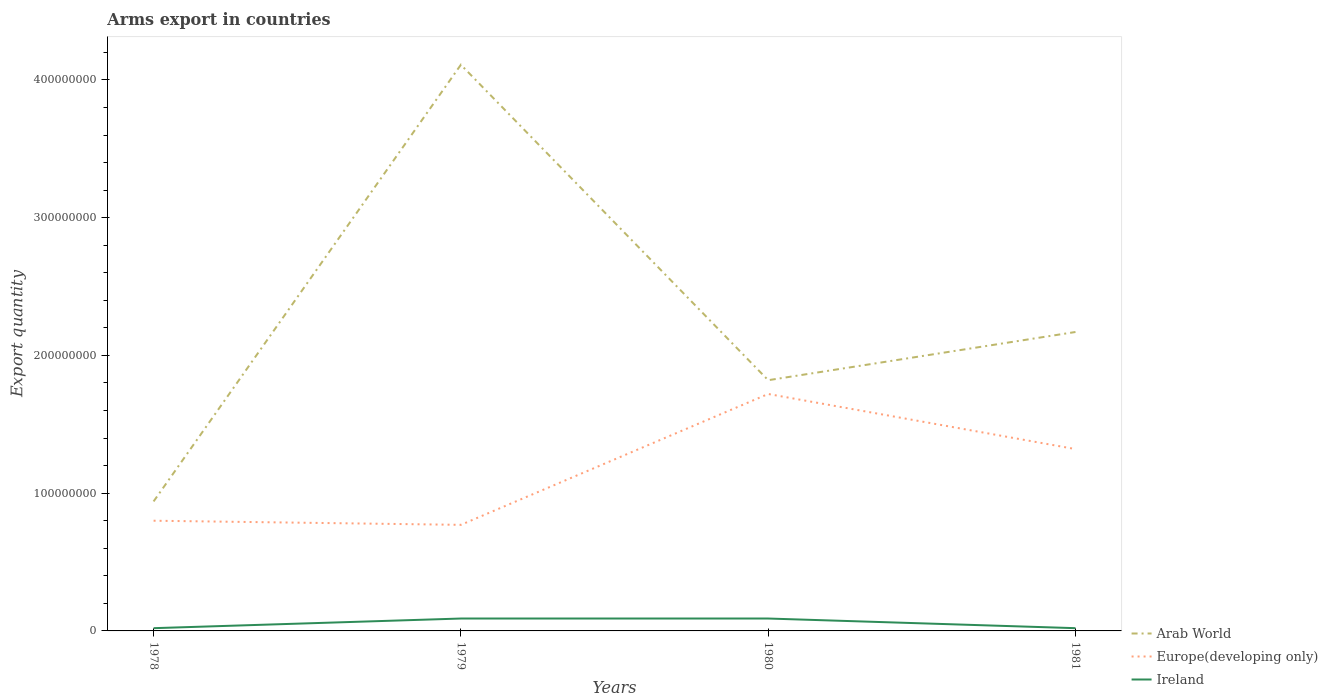Is the number of lines equal to the number of legend labels?
Offer a very short reply. Yes. Across all years, what is the maximum total arms export in Ireland?
Ensure brevity in your answer.  2.00e+06. In which year was the total arms export in Europe(developing only) maximum?
Your response must be concise. 1979. What is the total total arms export in Europe(developing only) in the graph?
Make the answer very short. -9.20e+07. What is the difference between the highest and the lowest total arms export in Europe(developing only)?
Offer a terse response. 2. Is the total arms export in Ireland strictly greater than the total arms export in Europe(developing only) over the years?
Make the answer very short. Yes. How many lines are there?
Provide a succinct answer. 3. Are the values on the major ticks of Y-axis written in scientific E-notation?
Ensure brevity in your answer.  No. Does the graph contain any zero values?
Offer a terse response. No. Does the graph contain grids?
Your answer should be very brief. No. Where does the legend appear in the graph?
Offer a terse response. Bottom right. How many legend labels are there?
Provide a short and direct response. 3. How are the legend labels stacked?
Give a very brief answer. Vertical. What is the title of the graph?
Provide a short and direct response. Arms export in countries. What is the label or title of the X-axis?
Offer a terse response. Years. What is the label or title of the Y-axis?
Make the answer very short. Export quantity. What is the Export quantity of Arab World in 1978?
Ensure brevity in your answer.  9.40e+07. What is the Export quantity in Europe(developing only) in 1978?
Keep it short and to the point. 8.00e+07. What is the Export quantity in Arab World in 1979?
Offer a very short reply. 4.11e+08. What is the Export quantity of Europe(developing only) in 1979?
Keep it short and to the point. 7.70e+07. What is the Export quantity of Ireland in 1979?
Your answer should be very brief. 9.00e+06. What is the Export quantity in Arab World in 1980?
Offer a terse response. 1.82e+08. What is the Export quantity in Europe(developing only) in 1980?
Your answer should be compact. 1.72e+08. What is the Export quantity of Ireland in 1980?
Keep it short and to the point. 9.00e+06. What is the Export quantity of Arab World in 1981?
Keep it short and to the point. 2.17e+08. What is the Export quantity of Europe(developing only) in 1981?
Keep it short and to the point. 1.32e+08. What is the Export quantity in Ireland in 1981?
Your answer should be very brief. 2.00e+06. Across all years, what is the maximum Export quantity of Arab World?
Ensure brevity in your answer.  4.11e+08. Across all years, what is the maximum Export quantity in Europe(developing only)?
Provide a short and direct response. 1.72e+08. Across all years, what is the maximum Export quantity in Ireland?
Ensure brevity in your answer.  9.00e+06. Across all years, what is the minimum Export quantity of Arab World?
Ensure brevity in your answer.  9.40e+07. Across all years, what is the minimum Export quantity of Europe(developing only)?
Make the answer very short. 7.70e+07. Across all years, what is the minimum Export quantity of Ireland?
Keep it short and to the point. 2.00e+06. What is the total Export quantity of Arab World in the graph?
Offer a very short reply. 9.04e+08. What is the total Export quantity of Europe(developing only) in the graph?
Provide a short and direct response. 4.61e+08. What is the total Export quantity of Ireland in the graph?
Ensure brevity in your answer.  2.20e+07. What is the difference between the Export quantity in Arab World in 1978 and that in 1979?
Your answer should be very brief. -3.17e+08. What is the difference between the Export quantity in Europe(developing only) in 1978 and that in 1979?
Your response must be concise. 3.00e+06. What is the difference between the Export quantity of Ireland in 1978 and that in 1979?
Provide a short and direct response. -7.00e+06. What is the difference between the Export quantity in Arab World in 1978 and that in 1980?
Provide a succinct answer. -8.80e+07. What is the difference between the Export quantity of Europe(developing only) in 1978 and that in 1980?
Offer a very short reply. -9.20e+07. What is the difference between the Export quantity of Ireland in 1978 and that in 1980?
Ensure brevity in your answer.  -7.00e+06. What is the difference between the Export quantity of Arab World in 1978 and that in 1981?
Keep it short and to the point. -1.23e+08. What is the difference between the Export quantity of Europe(developing only) in 1978 and that in 1981?
Your answer should be compact. -5.20e+07. What is the difference between the Export quantity in Arab World in 1979 and that in 1980?
Keep it short and to the point. 2.29e+08. What is the difference between the Export quantity of Europe(developing only) in 1979 and that in 1980?
Make the answer very short. -9.50e+07. What is the difference between the Export quantity in Ireland in 1979 and that in 1980?
Keep it short and to the point. 0. What is the difference between the Export quantity in Arab World in 1979 and that in 1981?
Provide a short and direct response. 1.94e+08. What is the difference between the Export quantity in Europe(developing only) in 1979 and that in 1981?
Your answer should be compact. -5.50e+07. What is the difference between the Export quantity in Arab World in 1980 and that in 1981?
Give a very brief answer. -3.50e+07. What is the difference between the Export quantity in Europe(developing only) in 1980 and that in 1981?
Your response must be concise. 4.00e+07. What is the difference between the Export quantity of Arab World in 1978 and the Export quantity of Europe(developing only) in 1979?
Make the answer very short. 1.70e+07. What is the difference between the Export quantity in Arab World in 1978 and the Export quantity in Ireland in 1979?
Offer a very short reply. 8.50e+07. What is the difference between the Export quantity of Europe(developing only) in 1978 and the Export quantity of Ireland in 1979?
Provide a short and direct response. 7.10e+07. What is the difference between the Export quantity in Arab World in 1978 and the Export quantity in Europe(developing only) in 1980?
Your response must be concise. -7.80e+07. What is the difference between the Export quantity of Arab World in 1978 and the Export quantity of Ireland in 1980?
Ensure brevity in your answer.  8.50e+07. What is the difference between the Export quantity of Europe(developing only) in 1978 and the Export quantity of Ireland in 1980?
Provide a short and direct response. 7.10e+07. What is the difference between the Export quantity in Arab World in 1978 and the Export quantity in Europe(developing only) in 1981?
Your answer should be compact. -3.80e+07. What is the difference between the Export quantity of Arab World in 1978 and the Export quantity of Ireland in 1981?
Your answer should be compact. 9.20e+07. What is the difference between the Export quantity of Europe(developing only) in 1978 and the Export quantity of Ireland in 1981?
Your answer should be compact. 7.80e+07. What is the difference between the Export quantity of Arab World in 1979 and the Export quantity of Europe(developing only) in 1980?
Make the answer very short. 2.39e+08. What is the difference between the Export quantity in Arab World in 1979 and the Export quantity in Ireland in 1980?
Offer a terse response. 4.02e+08. What is the difference between the Export quantity of Europe(developing only) in 1979 and the Export quantity of Ireland in 1980?
Your answer should be very brief. 6.80e+07. What is the difference between the Export quantity of Arab World in 1979 and the Export quantity of Europe(developing only) in 1981?
Make the answer very short. 2.79e+08. What is the difference between the Export quantity of Arab World in 1979 and the Export quantity of Ireland in 1981?
Your response must be concise. 4.09e+08. What is the difference between the Export quantity of Europe(developing only) in 1979 and the Export quantity of Ireland in 1981?
Provide a succinct answer. 7.50e+07. What is the difference between the Export quantity in Arab World in 1980 and the Export quantity in Ireland in 1981?
Provide a short and direct response. 1.80e+08. What is the difference between the Export quantity of Europe(developing only) in 1980 and the Export quantity of Ireland in 1981?
Offer a terse response. 1.70e+08. What is the average Export quantity in Arab World per year?
Offer a very short reply. 2.26e+08. What is the average Export quantity in Europe(developing only) per year?
Provide a succinct answer. 1.15e+08. What is the average Export quantity of Ireland per year?
Your answer should be compact. 5.50e+06. In the year 1978, what is the difference between the Export quantity of Arab World and Export quantity of Europe(developing only)?
Provide a short and direct response. 1.40e+07. In the year 1978, what is the difference between the Export quantity in Arab World and Export quantity in Ireland?
Offer a very short reply. 9.20e+07. In the year 1978, what is the difference between the Export quantity in Europe(developing only) and Export quantity in Ireland?
Ensure brevity in your answer.  7.80e+07. In the year 1979, what is the difference between the Export quantity in Arab World and Export quantity in Europe(developing only)?
Your answer should be very brief. 3.34e+08. In the year 1979, what is the difference between the Export quantity in Arab World and Export quantity in Ireland?
Keep it short and to the point. 4.02e+08. In the year 1979, what is the difference between the Export quantity of Europe(developing only) and Export quantity of Ireland?
Offer a very short reply. 6.80e+07. In the year 1980, what is the difference between the Export quantity of Arab World and Export quantity of Ireland?
Your answer should be very brief. 1.73e+08. In the year 1980, what is the difference between the Export quantity in Europe(developing only) and Export quantity in Ireland?
Provide a succinct answer. 1.63e+08. In the year 1981, what is the difference between the Export quantity of Arab World and Export quantity of Europe(developing only)?
Offer a terse response. 8.50e+07. In the year 1981, what is the difference between the Export quantity of Arab World and Export quantity of Ireland?
Your answer should be very brief. 2.15e+08. In the year 1981, what is the difference between the Export quantity in Europe(developing only) and Export quantity in Ireland?
Your response must be concise. 1.30e+08. What is the ratio of the Export quantity of Arab World in 1978 to that in 1979?
Offer a terse response. 0.23. What is the ratio of the Export quantity of Europe(developing only) in 1978 to that in 1979?
Ensure brevity in your answer.  1.04. What is the ratio of the Export quantity in Ireland in 1978 to that in 1979?
Offer a very short reply. 0.22. What is the ratio of the Export quantity in Arab World in 1978 to that in 1980?
Offer a very short reply. 0.52. What is the ratio of the Export quantity in Europe(developing only) in 1978 to that in 1980?
Give a very brief answer. 0.47. What is the ratio of the Export quantity in Ireland in 1978 to that in 1980?
Keep it short and to the point. 0.22. What is the ratio of the Export quantity in Arab World in 1978 to that in 1981?
Offer a very short reply. 0.43. What is the ratio of the Export quantity of Europe(developing only) in 1978 to that in 1981?
Offer a very short reply. 0.61. What is the ratio of the Export quantity of Ireland in 1978 to that in 1981?
Keep it short and to the point. 1. What is the ratio of the Export quantity of Arab World in 1979 to that in 1980?
Ensure brevity in your answer.  2.26. What is the ratio of the Export quantity of Europe(developing only) in 1979 to that in 1980?
Provide a short and direct response. 0.45. What is the ratio of the Export quantity in Arab World in 1979 to that in 1981?
Offer a very short reply. 1.89. What is the ratio of the Export quantity of Europe(developing only) in 1979 to that in 1981?
Provide a short and direct response. 0.58. What is the ratio of the Export quantity of Ireland in 1979 to that in 1981?
Ensure brevity in your answer.  4.5. What is the ratio of the Export quantity of Arab World in 1980 to that in 1981?
Your answer should be compact. 0.84. What is the ratio of the Export quantity in Europe(developing only) in 1980 to that in 1981?
Keep it short and to the point. 1.3. What is the difference between the highest and the second highest Export quantity in Arab World?
Provide a succinct answer. 1.94e+08. What is the difference between the highest and the second highest Export quantity in Europe(developing only)?
Your answer should be very brief. 4.00e+07. What is the difference between the highest and the lowest Export quantity in Arab World?
Give a very brief answer. 3.17e+08. What is the difference between the highest and the lowest Export quantity of Europe(developing only)?
Provide a short and direct response. 9.50e+07. 